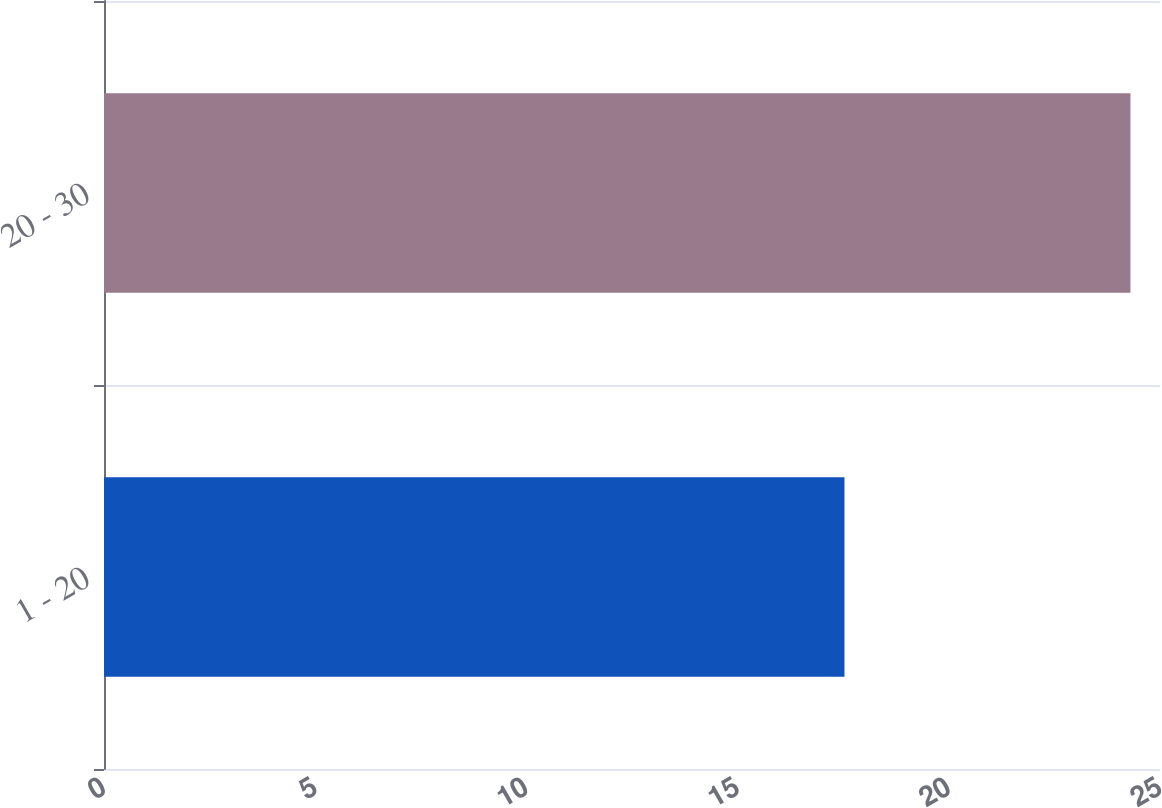<chart> <loc_0><loc_0><loc_500><loc_500><bar_chart><fcel>1 - 20<fcel>20 - 30<nl><fcel>17.53<fcel>24.3<nl></chart> 